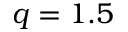<formula> <loc_0><loc_0><loc_500><loc_500>q = 1 . 5</formula> 